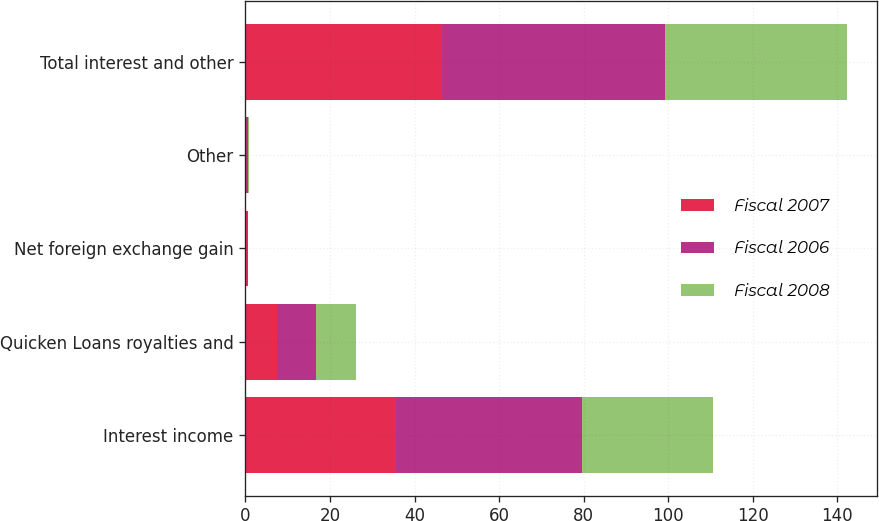<chart> <loc_0><loc_0><loc_500><loc_500><stacked_bar_chart><ecel><fcel>Interest income<fcel>Quicken Loans royalties and<fcel>Net foreign exchange gain<fcel>Other<fcel>Total interest and other<nl><fcel>Fiscal 2007<fcel>35.6<fcel>7.5<fcel>0.5<fcel>0.2<fcel>46.5<nl><fcel>Fiscal 2006<fcel>44<fcel>9.3<fcel>0.1<fcel>0.5<fcel>52.7<nl><fcel>Fiscal 2008<fcel>31<fcel>9.3<fcel>0.1<fcel>0.2<fcel>43<nl></chart> 